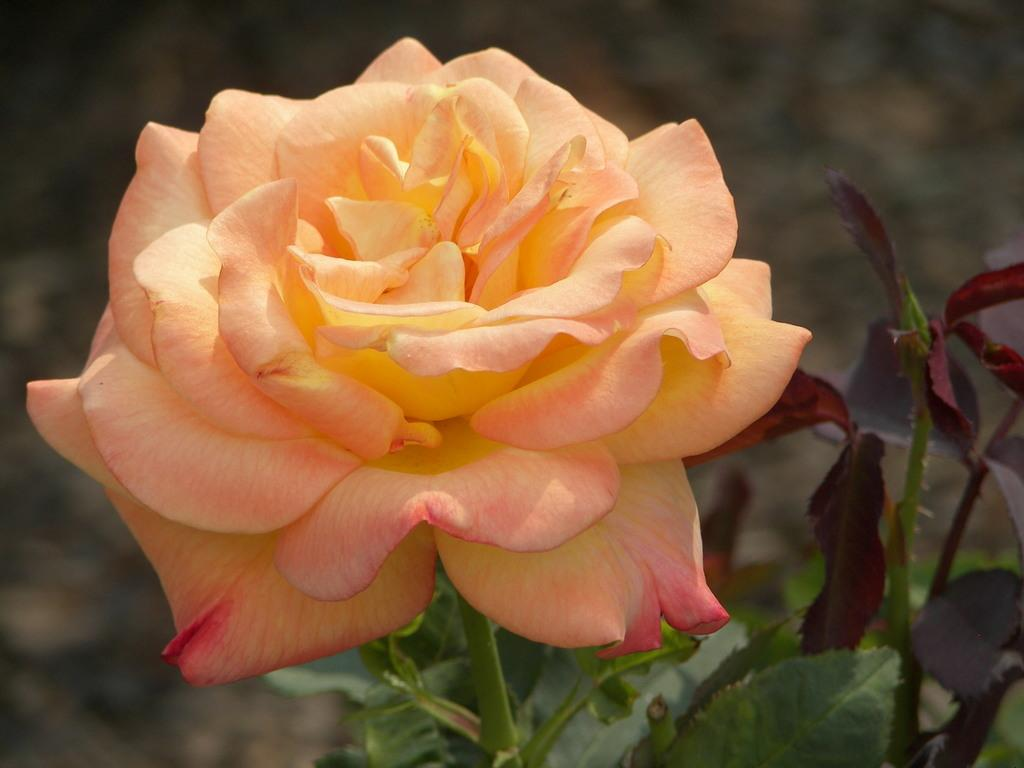What type of plant is visible in the image? There is a plant in the image. What features can be observed on the plant? The plant has leaves and thorns on its stem. What type of flower is present on the plant? There is a rose on the stem of the plant. Can you describe the background of the image? The background of the image is blurry. What type of board game is being played in the image? There is no board game present in the image; it features a plant with a rose and a blurry background. 